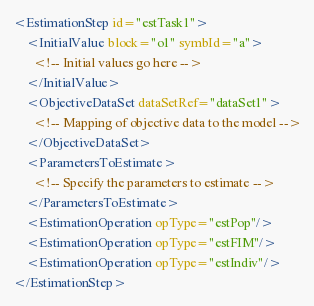Convert code to text. <code><loc_0><loc_0><loc_500><loc_500><_XML_><EstimationStep id="estTask1">
    <InitialValue block="o1" symbId="a">
      <!-- Initial values go here -->
    </InitialValue>
    <ObjectiveDataSet dataSetRef="dataSet1">
      <!-- Mapping of objective data to the model -->
    </ObjectiveDataSet>
    <ParametersToEstimate>
      <!-- Specify the parameters to estimate -->
    </ParametersToEstimate>
    <EstimationOperation opType="estPop"/>
    <EstimationOperation opType="estFIM"/>
    <EstimationOperation opType="estIndiv"/>
</EstimationStep>
</code> 